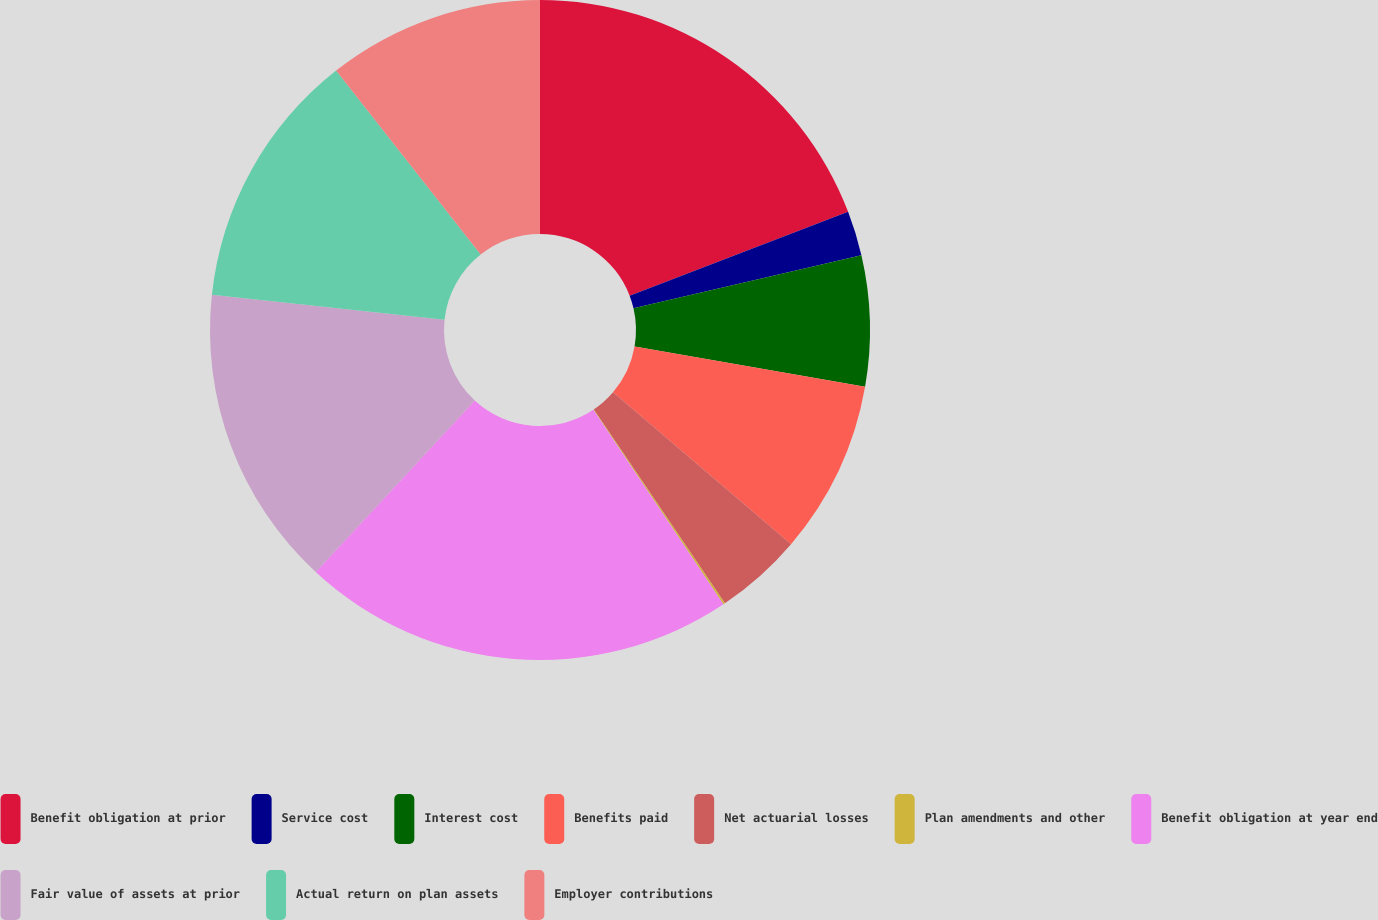Convert chart to OTSL. <chart><loc_0><loc_0><loc_500><loc_500><pie_chart><fcel>Benefit obligation at prior<fcel>Service cost<fcel>Interest cost<fcel>Benefits paid<fcel>Net actuarial losses<fcel>Plan amendments and other<fcel>Benefit obligation at year end<fcel>Fair value of assets at prior<fcel>Actual return on plan assets<fcel>Employer contributions<nl><fcel>19.17%<fcel>2.19%<fcel>6.39%<fcel>8.49%<fcel>4.29%<fcel>0.09%<fcel>21.27%<fcel>14.8%<fcel>12.7%<fcel>10.6%<nl></chart> 